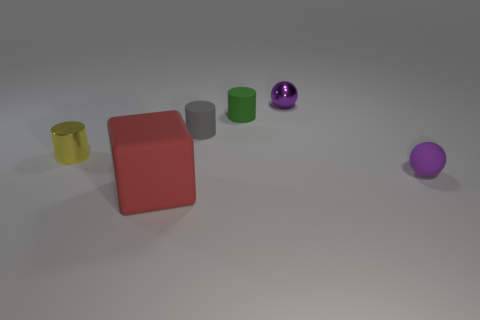Subtract all yellow cubes. Subtract all cyan cylinders. How many cubes are left? 1 Add 3 shiny balls. How many objects exist? 9 Subtract all balls. How many objects are left? 4 Add 4 large red rubber things. How many large red rubber things are left? 5 Add 4 brown matte things. How many brown matte things exist? 4 Subtract 0 cyan cylinders. How many objects are left? 6 Subtract all tiny green rubber things. Subtract all tiny green rubber cylinders. How many objects are left? 4 